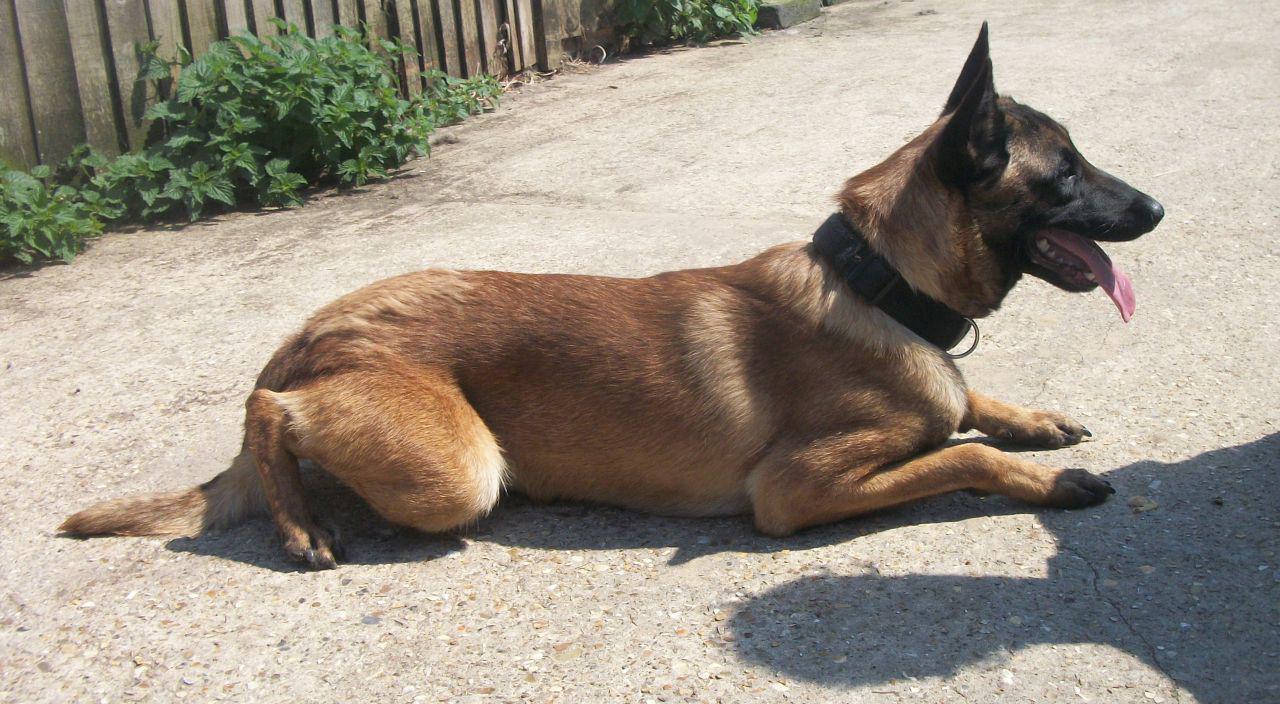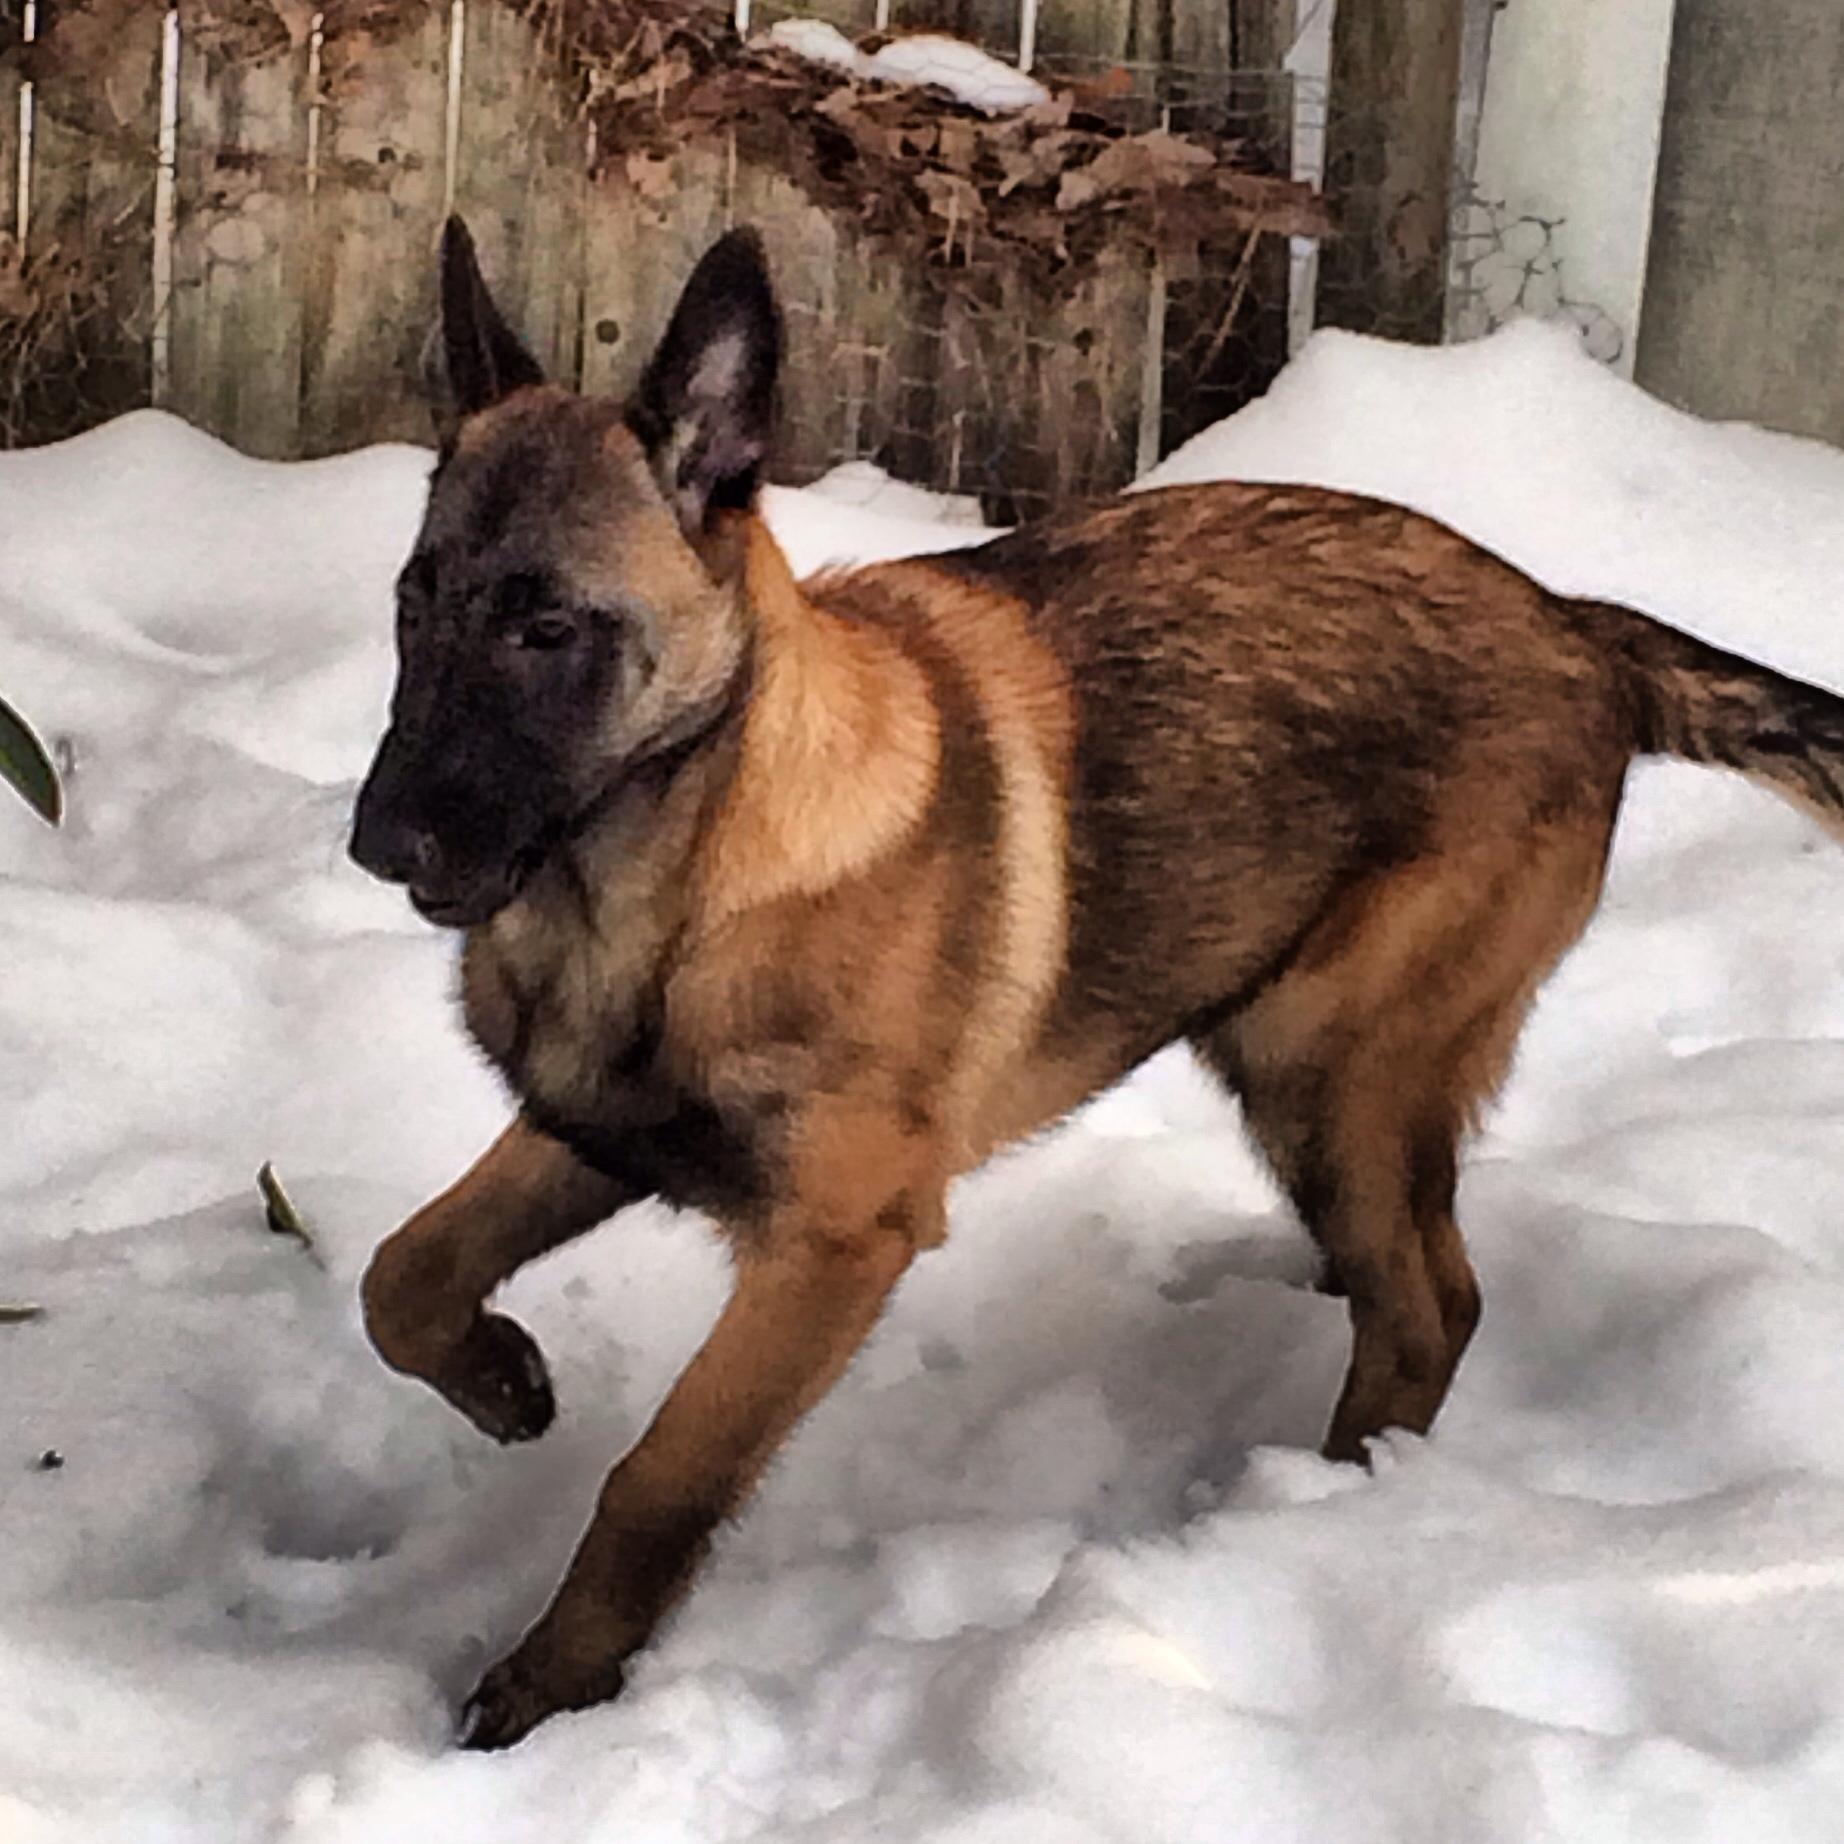The first image is the image on the left, the second image is the image on the right. Considering the images on both sides, is "In one of the images, the dog is on a tile floor." valid? Answer yes or no. No. The first image is the image on the left, the second image is the image on the right. Examine the images to the left and right. Is the description "Each image contains one german shepherd, and the right image shows a dog moving toward the lower left." accurate? Answer yes or no. Yes. 